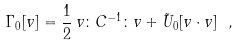<formula> <loc_0><loc_0><loc_500><loc_500>\Gamma _ { 0 } [ v ] = \frac { 1 } { 2 } \, v \colon C ^ { - 1 } \colon v + \tilde { U } _ { 0 } [ v \cdot v ] \ ,</formula> 